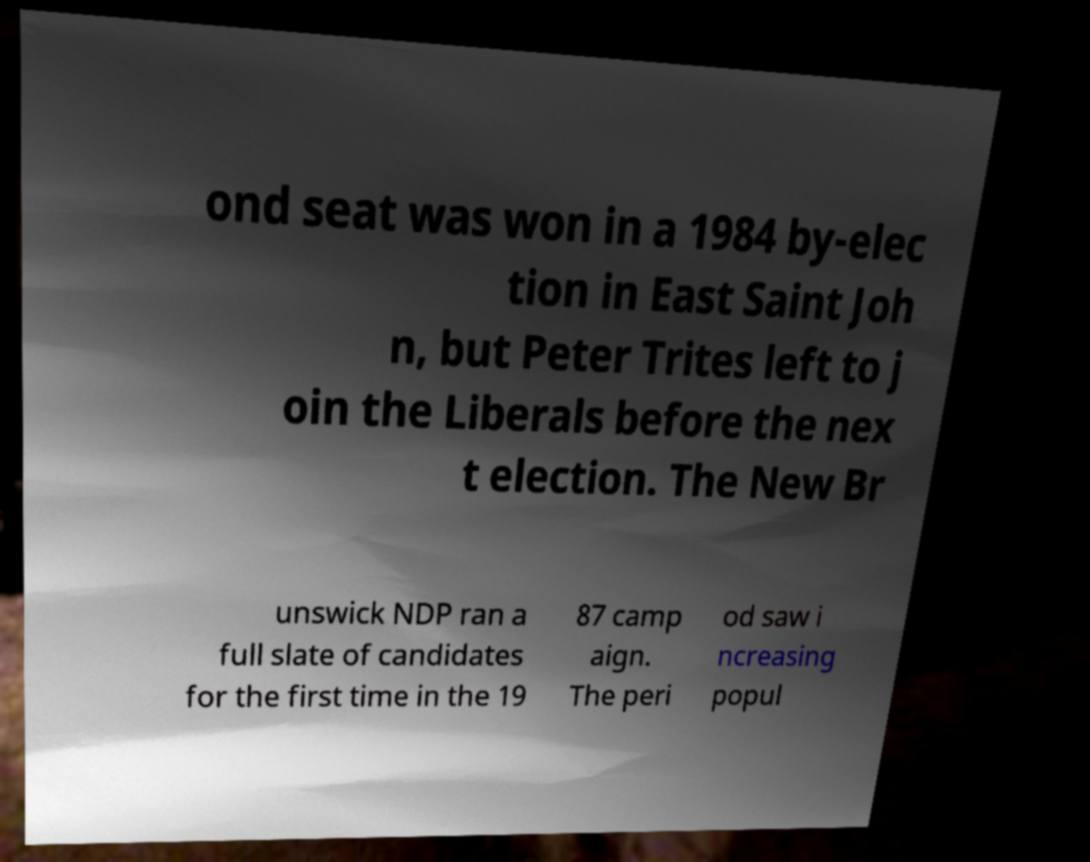Can you read and provide the text displayed in the image?This photo seems to have some interesting text. Can you extract and type it out for me? ond seat was won in a 1984 by-elec tion in East Saint Joh n, but Peter Trites left to j oin the Liberals before the nex t election. The New Br unswick NDP ran a full slate of candidates for the first time in the 19 87 camp aign. The peri od saw i ncreasing popul 